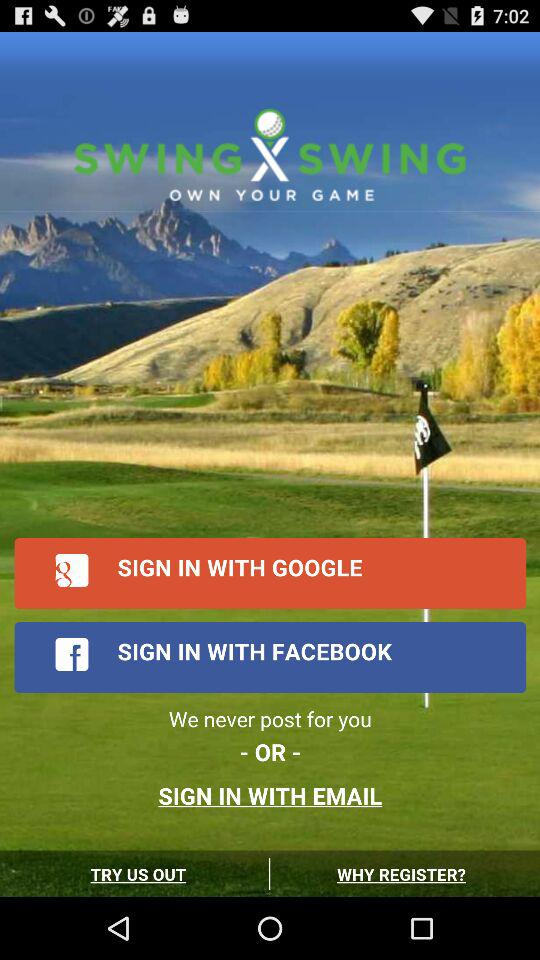What is the name of the application? The name of the application is "SWING X SWING". 